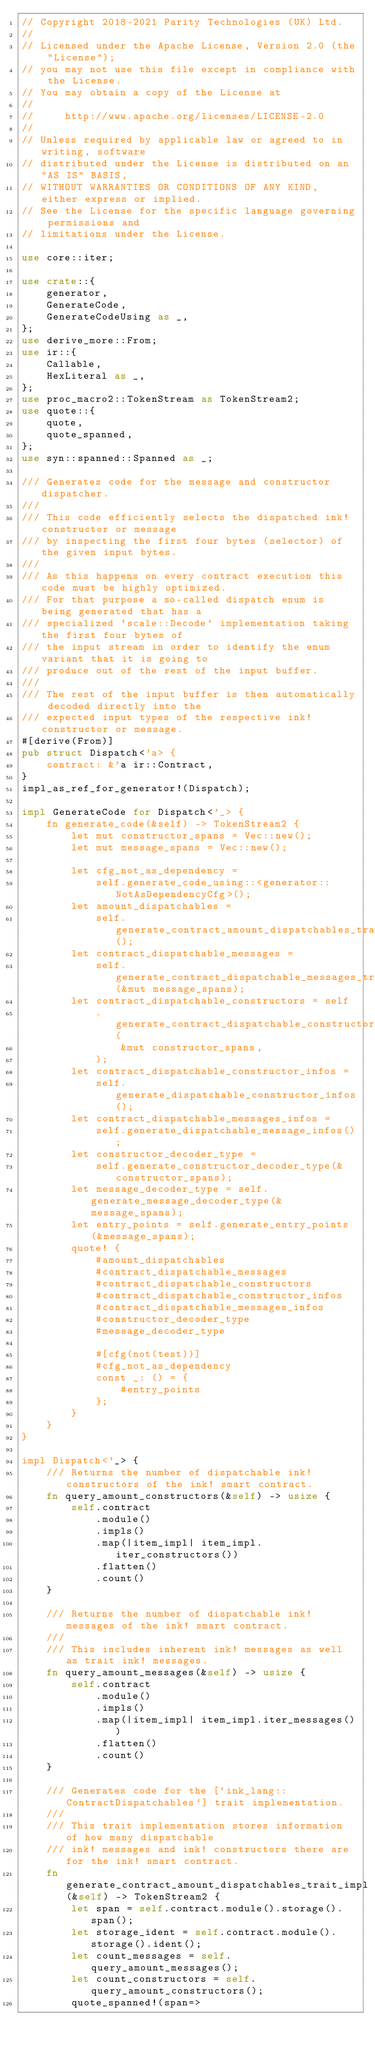<code> <loc_0><loc_0><loc_500><loc_500><_Rust_>// Copyright 2018-2021 Parity Technologies (UK) Ltd.
//
// Licensed under the Apache License, Version 2.0 (the "License");
// you may not use this file except in compliance with the License.
// You may obtain a copy of the License at
//
//     http://www.apache.org/licenses/LICENSE-2.0
//
// Unless required by applicable law or agreed to in writing, software
// distributed under the License is distributed on an "AS IS" BASIS,
// WITHOUT WARRANTIES OR CONDITIONS OF ANY KIND, either express or implied.
// See the License for the specific language governing permissions and
// limitations under the License.

use core::iter;

use crate::{
    generator,
    GenerateCode,
    GenerateCodeUsing as _,
};
use derive_more::From;
use ir::{
    Callable,
    HexLiteral as _,
};
use proc_macro2::TokenStream as TokenStream2;
use quote::{
    quote,
    quote_spanned,
};
use syn::spanned::Spanned as _;

/// Generates code for the message and constructor dispatcher.
///
/// This code efficiently selects the dispatched ink! constructor or message
/// by inspecting the first four bytes (selector) of the given input bytes.
///
/// As this happens on every contract execution this code must be highly optimized.
/// For that purpose a so-called dispatch enum is being generated that has a
/// specialized `scale::Decode` implementation taking the first four bytes of
/// the input stream in order to identify the enum variant that it is going to
/// produce out of the rest of the input buffer.
///
/// The rest of the input buffer is then automatically decoded directly into the
/// expected input types of the respective ink! constructor or message.
#[derive(From)]
pub struct Dispatch<'a> {
    contract: &'a ir::Contract,
}
impl_as_ref_for_generator!(Dispatch);

impl GenerateCode for Dispatch<'_> {
    fn generate_code(&self) -> TokenStream2 {
        let mut constructor_spans = Vec::new();
        let mut message_spans = Vec::new();

        let cfg_not_as_dependency =
            self.generate_code_using::<generator::NotAsDependencyCfg>();
        let amount_dispatchables =
            self.generate_contract_amount_dispatchables_trait_impl();
        let contract_dispatchable_messages =
            self.generate_contract_dispatchable_messages_trait_impl(&mut message_spans);
        let contract_dispatchable_constructors = self
            .generate_contract_dispatchable_constructors_trait_impl(
                &mut constructor_spans,
            );
        let contract_dispatchable_constructor_infos =
            self.generate_dispatchable_constructor_infos();
        let contract_dispatchable_messages_infos =
            self.generate_dispatchable_message_infos();
        let constructor_decoder_type =
            self.generate_constructor_decoder_type(&constructor_spans);
        let message_decoder_type = self.generate_message_decoder_type(&message_spans);
        let entry_points = self.generate_entry_points(&message_spans);
        quote! {
            #amount_dispatchables
            #contract_dispatchable_messages
            #contract_dispatchable_constructors
            #contract_dispatchable_constructor_infos
            #contract_dispatchable_messages_infos
            #constructor_decoder_type
            #message_decoder_type

            #[cfg(not(test))]
            #cfg_not_as_dependency
            const _: () = {
                #entry_points
            };
        }
    }
}

impl Dispatch<'_> {
    /// Returns the number of dispatchable ink! constructors of the ink! smart contract.
    fn query_amount_constructors(&self) -> usize {
        self.contract
            .module()
            .impls()
            .map(|item_impl| item_impl.iter_constructors())
            .flatten()
            .count()
    }

    /// Returns the number of dispatchable ink! messages of the ink! smart contract.
    ///
    /// This includes inherent ink! messages as well as trait ink! messages.
    fn query_amount_messages(&self) -> usize {
        self.contract
            .module()
            .impls()
            .map(|item_impl| item_impl.iter_messages())
            .flatten()
            .count()
    }

    /// Generates code for the [`ink_lang::ContractDispatchables`] trait implementation.
    ///
    /// This trait implementation stores information of how many dispatchable
    /// ink! messages and ink! constructors there are for the ink! smart contract.
    fn generate_contract_amount_dispatchables_trait_impl(&self) -> TokenStream2 {
        let span = self.contract.module().storage().span();
        let storage_ident = self.contract.module().storage().ident();
        let count_messages = self.query_amount_messages();
        let count_constructors = self.query_amount_constructors();
        quote_spanned!(span=></code> 